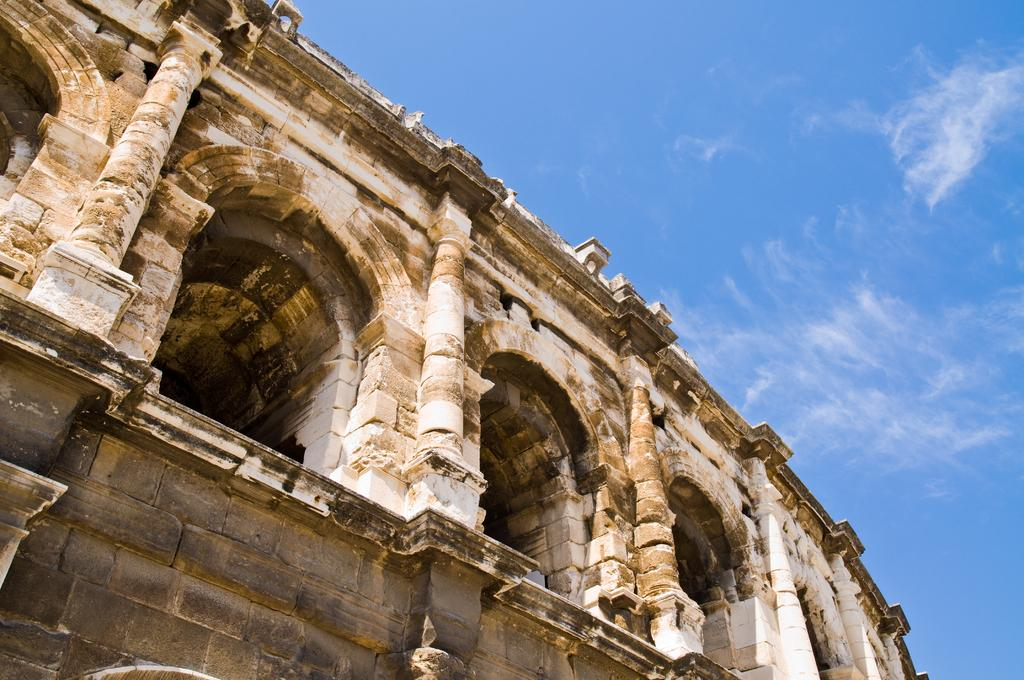What is the main structure in the image? There is a stone monument in the image. What can be seen in the background of the image? The sky is visible at the top of the image. Where is the store located in the image? There is no store present in the image. What type of throne can be seen in the image? There is no throne present in the image. 